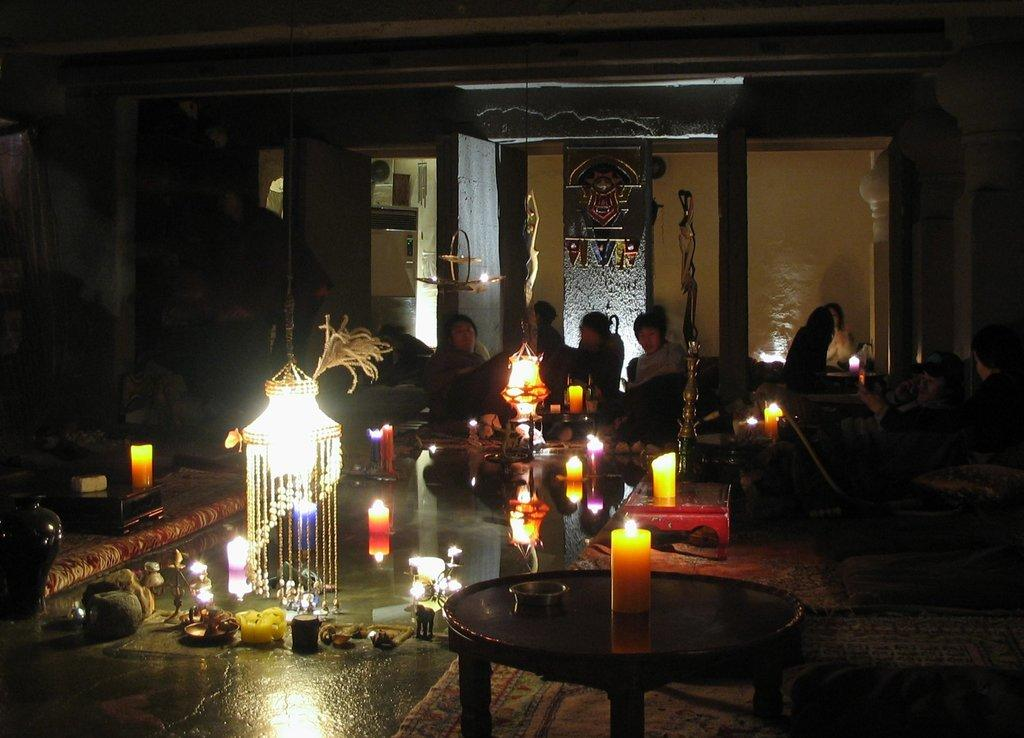Who or what can be seen in the image? There are people in the image. What objects are present that might provide light? There are candles and lights in the image. What type of structure is visible in the background? There is a wall in the image. What type of card is being used to extinguish the candles in the image? There is no card present in the image, and the candles are not being extinguished. 